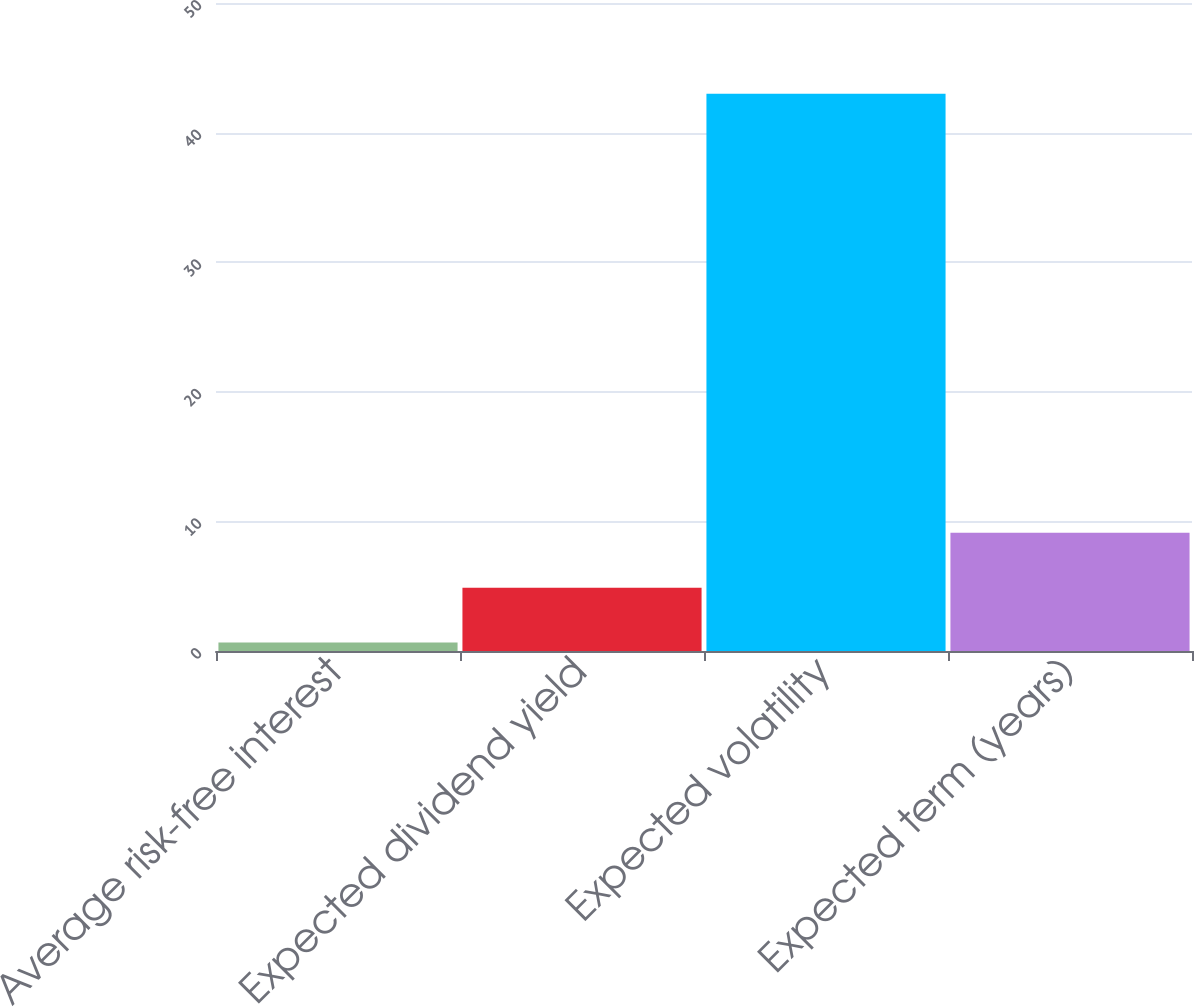Convert chart. <chart><loc_0><loc_0><loc_500><loc_500><bar_chart><fcel>Average risk-free interest<fcel>Expected dividend yield<fcel>Expected volatility<fcel>Expected term (years)<nl><fcel>0.66<fcel>4.89<fcel>43<fcel>9.12<nl></chart> 